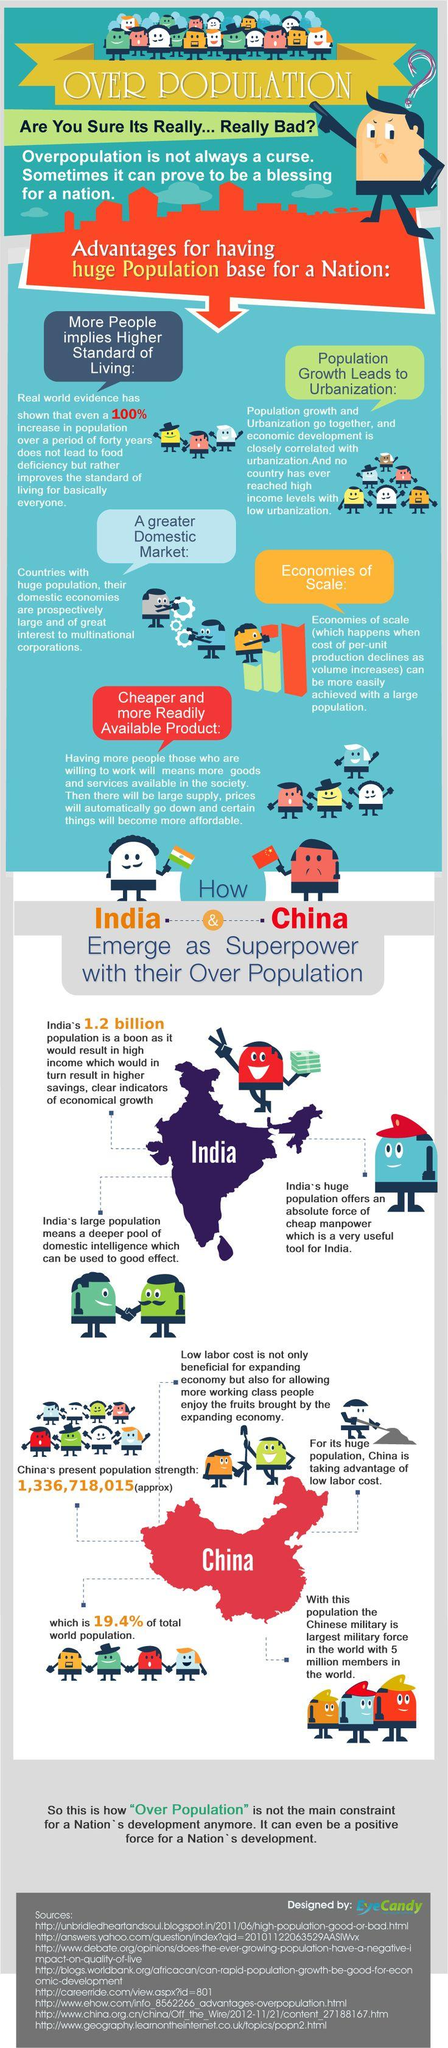Identify some key points in this picture. There is one Indian flag present in this infographic. 